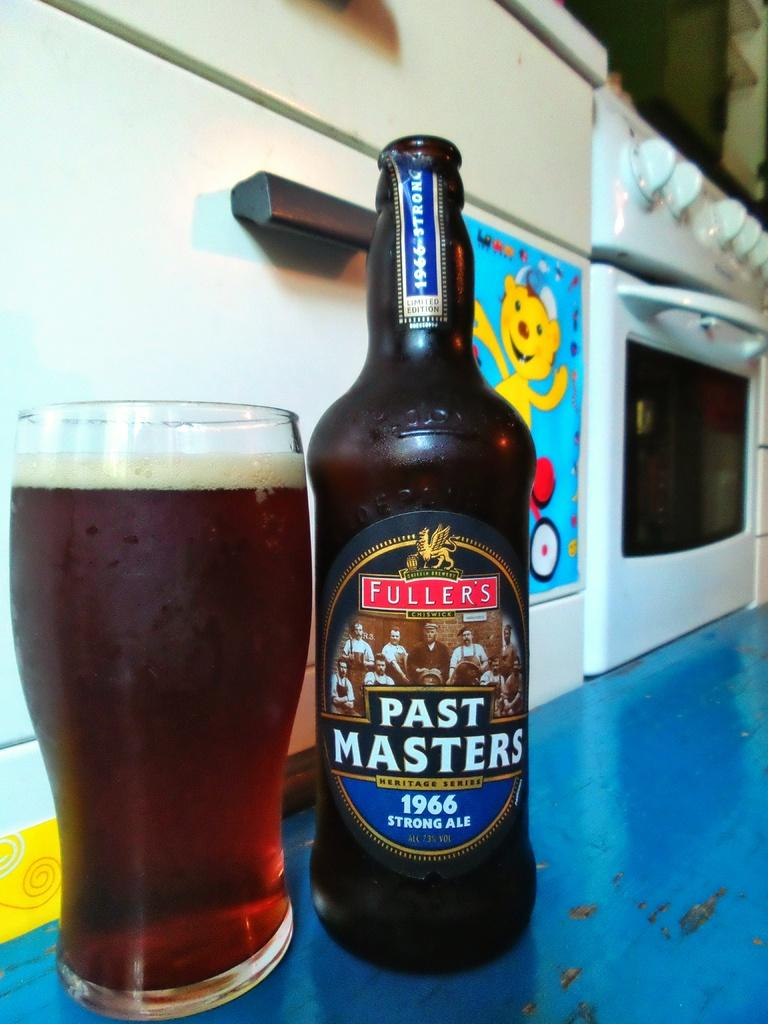<image>
Render a clear and concise summary of the photo. A bottle of Past Masters beer beside a full glass. 